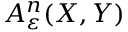Convert formula to latex. <formula><loc_0><loc_0><loc_500><loc_500>A _ { \varepsilon } ^ { n } ( X , Y )</formula> 